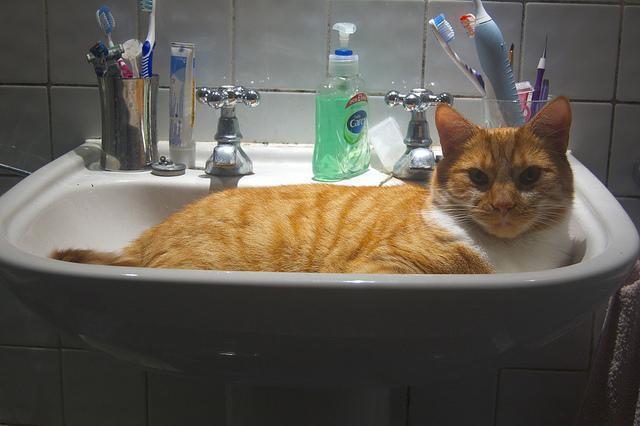How many bottles are in the picture?
Give a very brief answer. 1. 